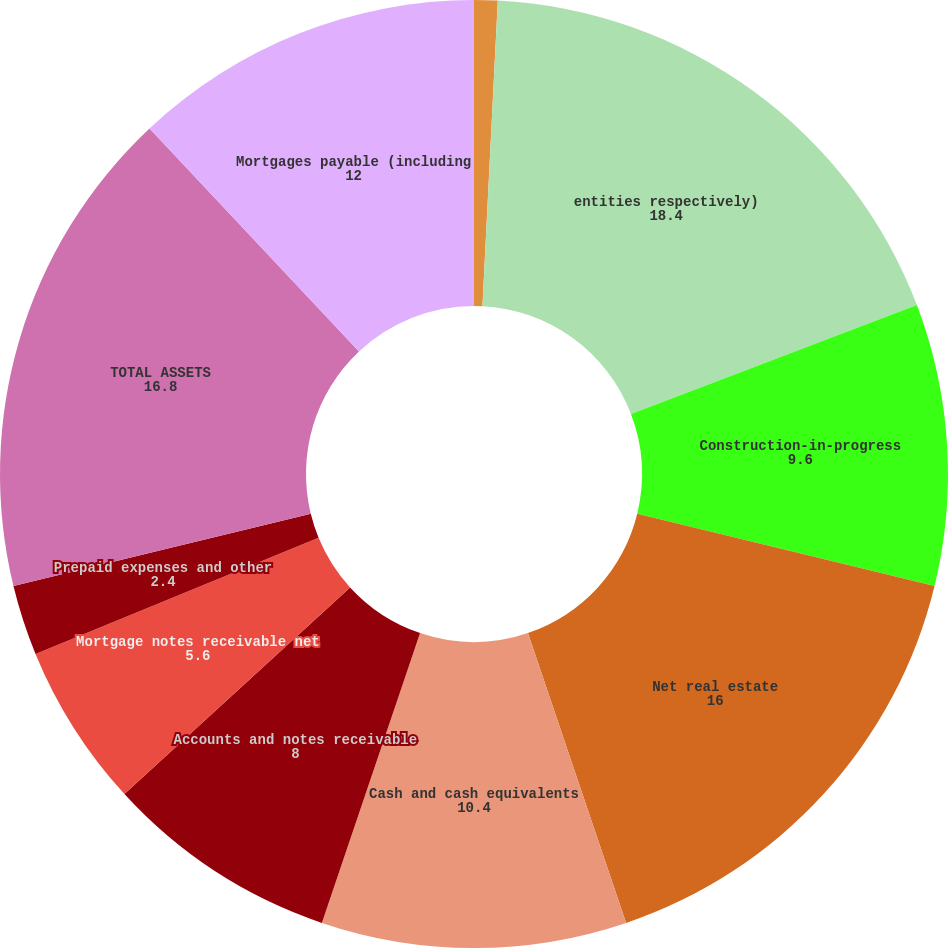<chart> <loc_0><loc_0><loc_500><loc_500><pie_chart><fcel>2010<fcel>entities respectively)<fcel>Construction-in-progress<fcel>Net real estate<fcel>Cash and cash equivalents<fcel>Accounts and notes receivable<fcel>Mortgage notes receivable net<fcel>Prepaid expenses and other<fcel>TOTAL ASSETS<fcel>Mortgages payable (including<nl><fcel>0.8%<fcel>18.4%<fcel>9.6%<fcel>16.0%<fcel>10.4%<fcel>8.0%<fcel>5.6%<fcel>2.4%<fcel>16.8%<fcel>12.0%<nl></chart> 